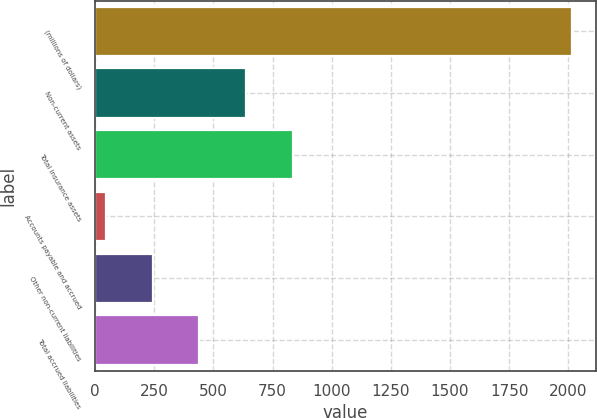Convert chart to OTSL. <chart><loc_0><loc_0><loc_500><loc_500><bar_chart><fcel>(millions of dollars)<fcel>Non-current assets<fcel>Total insurance assets<fcel>Accounts payable and accrued<fcel>Other non-current liabilities<fcel>Total accrued liabilities<nl><fcel>2015<fcel>637.89<fcel>834.62<fcel>47.7<fcel>244.43<fcel>441.16<nl></chart> 